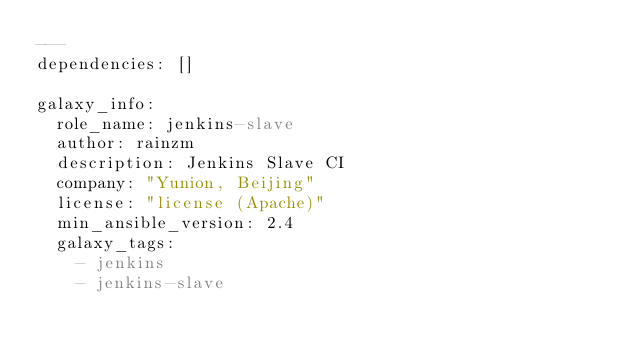<code> <loc_0><loc_0><loc_500><loc_500><_YAML_>---
dependencies: []

galaxy_info:
  role_name: jenkins-slave
  author: rainzm
  description: Jenkins Slave CI
  company: "Yunion, Beijing"
  license: "license (Apache)"
  min_ansible_version: 2.4
  galaxy_tags:
    - jenkins
    - jenkins-slave
</code> 